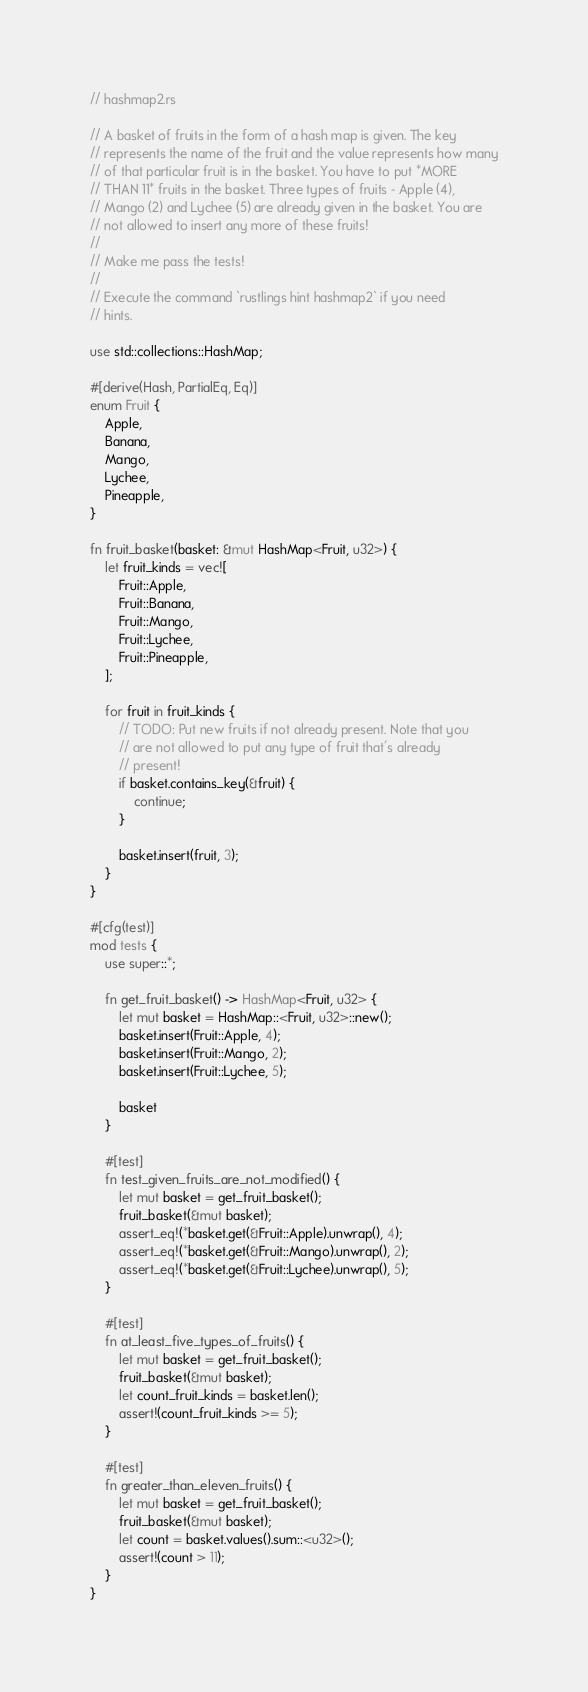Convert code to text. <code><loc_0><loc_0><loc_500><loc_500><_Rust_>// hashmap2.rs

// A basket of fruits in the form of a hash map is given. The key
// represents the name of the fruit and the value represents how many
// of that particular fruit is in the basket. You have to put *MORE
// THAN 11* fruits in the basket. Three types of fruits - Apple (4),
// Mango (2) and Lychee (5) are already given in the basket. You are
// not allowed to insert any more of these fruits!
//
// Make me pass the tests!
//
// Execute the command `rustlings hint hashmap2` if you need
// hints.

use std::collections::HashMap;

#[derive(Hash, PartialEq, Eq)]
enum Fruit {
    Apple,
    Banana,
    Mango,
    Lychee,
    Pineapple,
}

fn fruit_basket(basket: &mut HashMap<Fruit, u32>) {
    let fruit_kinds = vec![
        Fruit::Apple,
        Fruit::Banana,
        Fruit::Mango,
        Fruit::Lychee,
        Fruit::Pineapple,
    ];

    for fruit in fruit_kinds {
        // TODO: Put new fruits if not already present. Note that you
        // are not allowed to put any type of fruit that's already
        // present!
        if basket.contains_key(&fruit) {
            continue;
        }

        basket.insert(fruit, 3);
    }
}

#[cfg(test)]
mod tests {
    use super::*;

    fn get_fruit_basket() -> HashMap<Fruit, u32> {
        let mut basket = HashMap::<Fruit, u32>::new();
        basket.insert(Fruit::Apple, 4);
        basket.insert(Fruit::Mango, 2);
        basket.insert(Fruit::Lychee, 5);

        basket
    }

    #[test]
    fn test_given_fruits_are_not_modified() {
        let mut basket = get_fruit_basket();
        fruit_basket(&mut basket);
        assert_eq!(*basket.get(&Fruit::Apple).unwrap(), 4);
        assert_eq!(*basket.get(&Fruit::Mango).unwrap(), 2);
        assert_eq!(*basket.get(&Fruit::Lychee).unwrap(), 5);
    }

    #[test]
    fn at_least_five_types_of_fruits() {
        let mut basket = get_fruit_basket();
        fruit_basket(&mut basket);
        let count_fruit_kinds = basket.len();
        assert!(count_fruit_kinds >= 5);
    }

    #[test]
    fn greater_than_eleven_fruits() {
        let mut basket = get_fruit_basket();
        fruit_basket(&mut basket);
        let count = basket.values().sum::<u32>();
        assert!(count > 11);
    }
}
</code> 